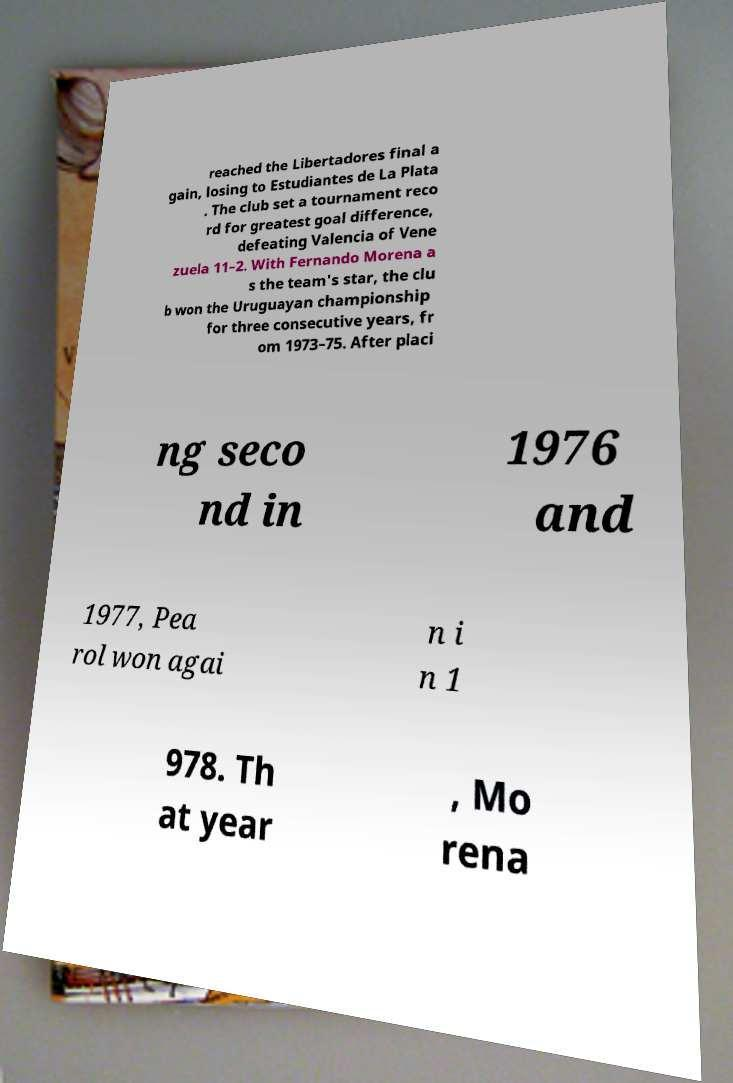There's text embedded in this image that I need extracted. Can you transcribe it verbatim? reached the Libertadores final a gain, losing to Estudiantes de La Plata . The club set a tournament reco rd for greatest goal difference, defeating Valencia of Vene zuela 11–2. With Fernando Morena a s the team's star, the clu b won the Uruguayan championship for three consecutive years, fr om 1973–75. After placi ng seco nd in 1976 and 1977, Pea rol won agai n i n 1 978. Th at year , Mo rena 